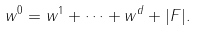Convert formula to latex. <formula><loc_0><loc_0><loc_500><loc_500>w ^ { 0 } = w ^ { 1 } + \cdots + w ^ { d } + | F | .</formula> 